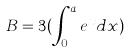Convert formula to latex. <formula><loc_0><loc_0><loc_500><loc_500>B = 3 ( \int _ { 0 } ^ { a } e ^ { x } d x )</formula> 